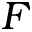Convert formula to latex. <formula><loc_0><loc_0><loc_500><loc_500>F</formula> 